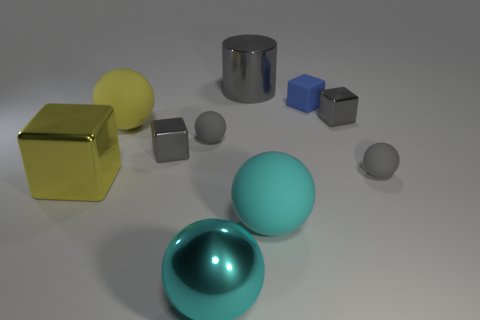Is the shadow of the big gray cylinder longer than the shadow of the blue cube? Yes, the shadow of the big gray cylinder is longer than that of the blue cube, indicating that the cylinder is taller or the light source is positioned in such a way that it casts a longer shadow. 